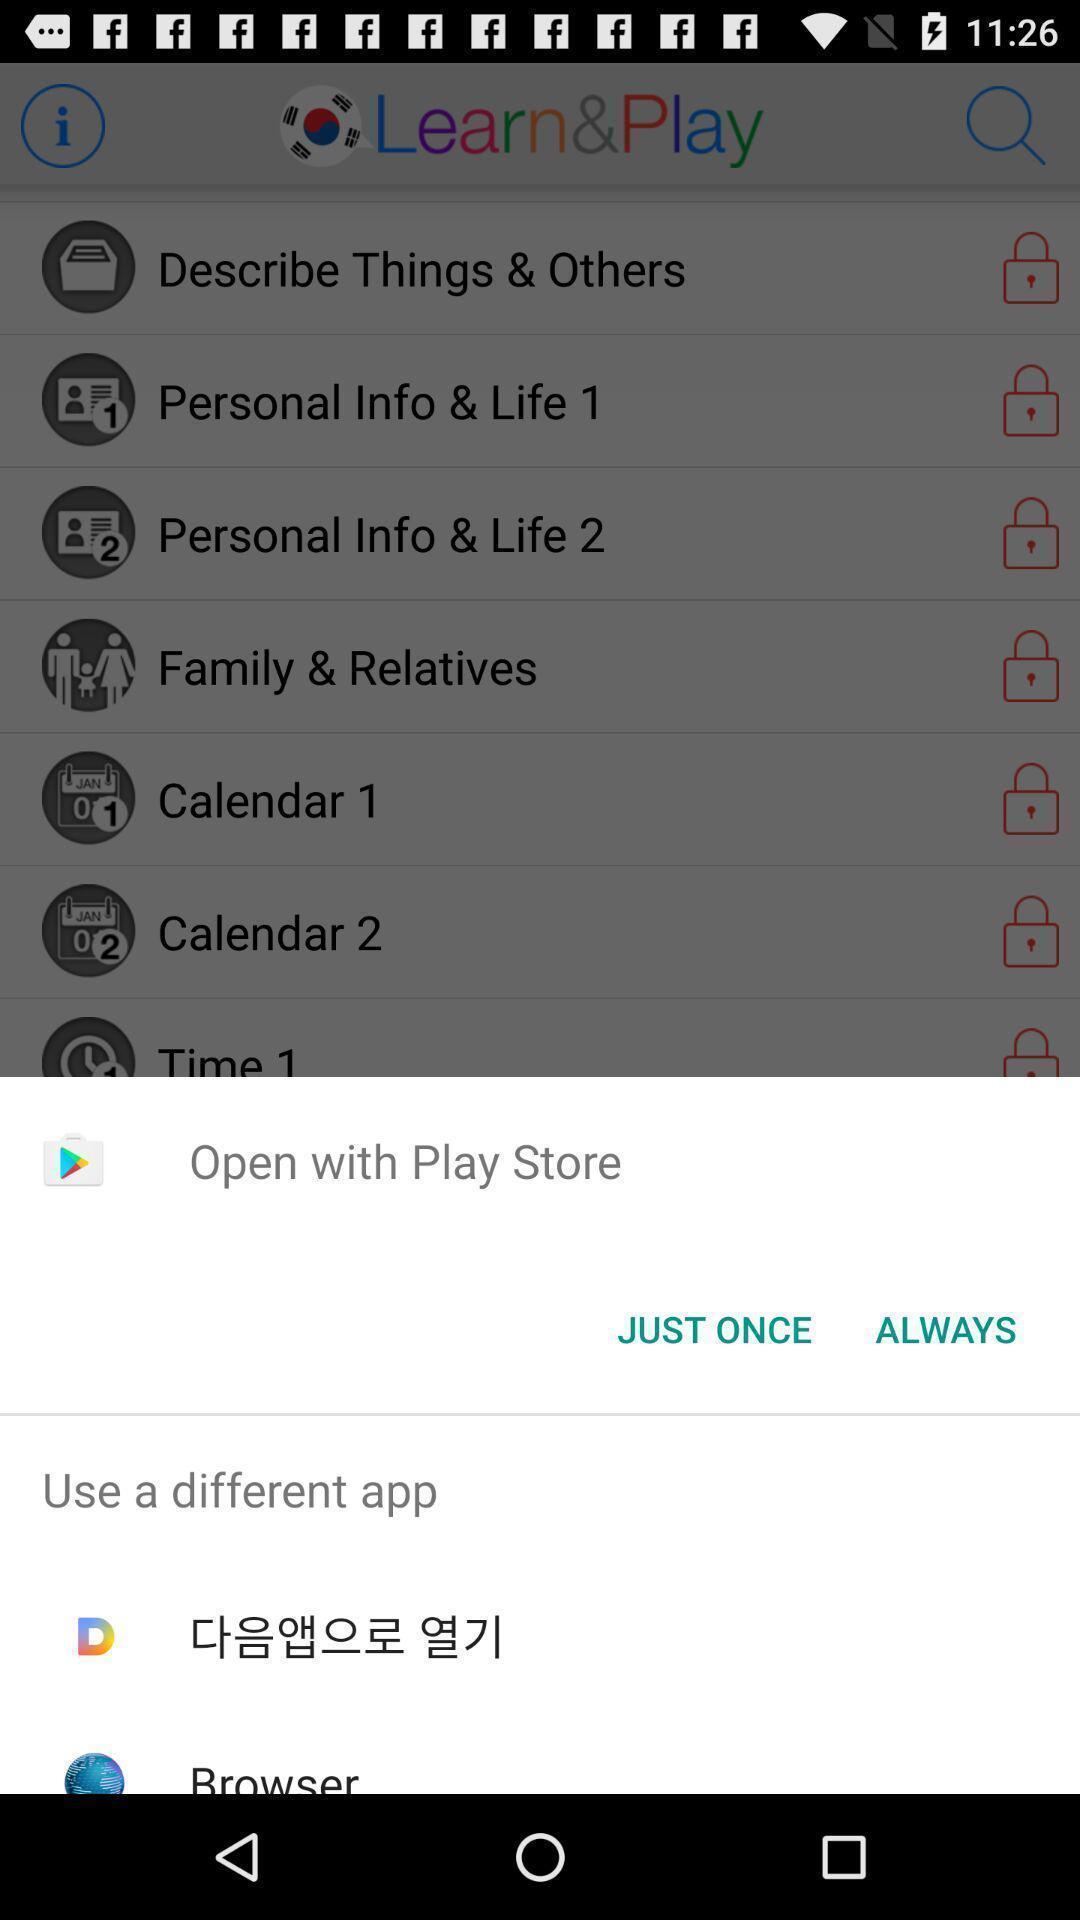Summarize the information in this screenshot. Popup to open for the learning app. 